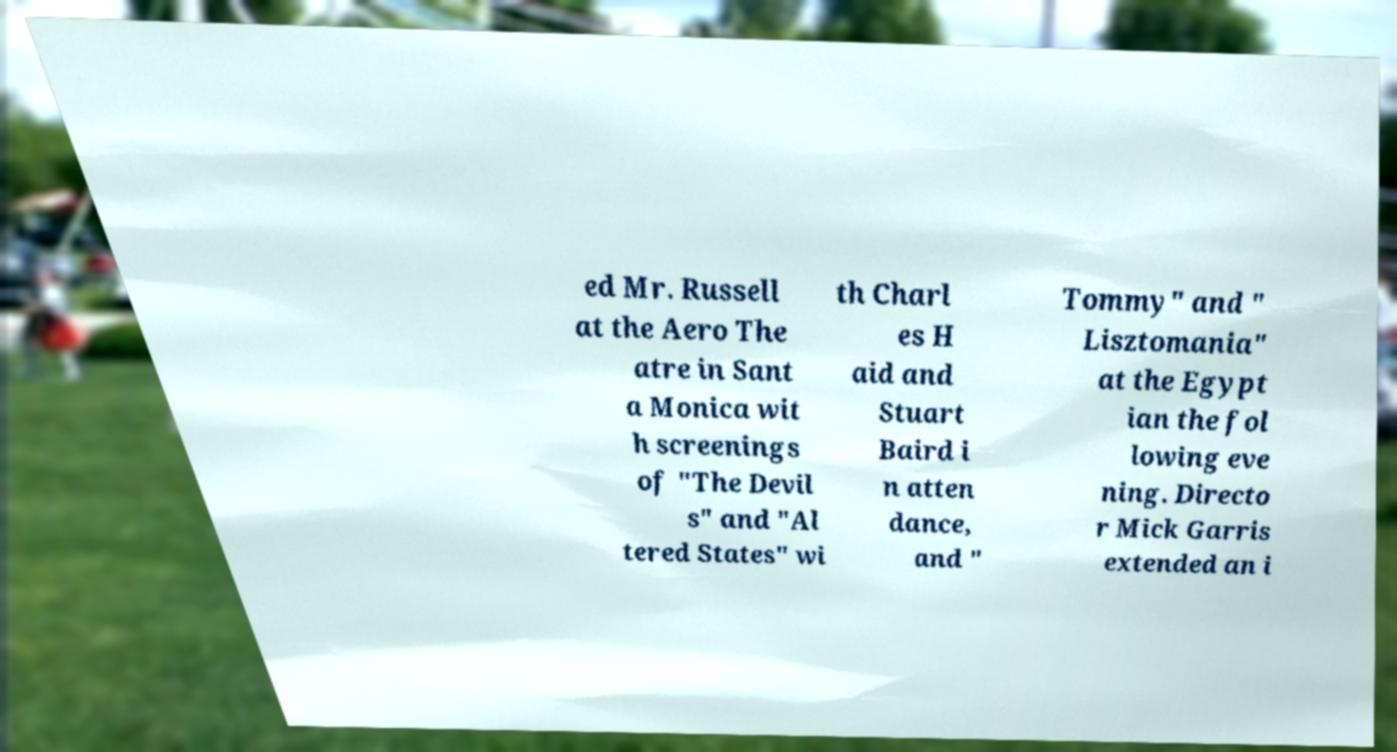Could you extract and type out the text from this image? ed Mr. Russell at the Aero The atre in Sant a Monica wit h screenings of "The Devil s" and "Al tered States" wi th Charl es H aid and Stuart Baird i n atten dance, and " Tommy" and " Lisztomania" at the Egypt ian the fol lowing eve ning. Directo r Mick Garris extended an i 